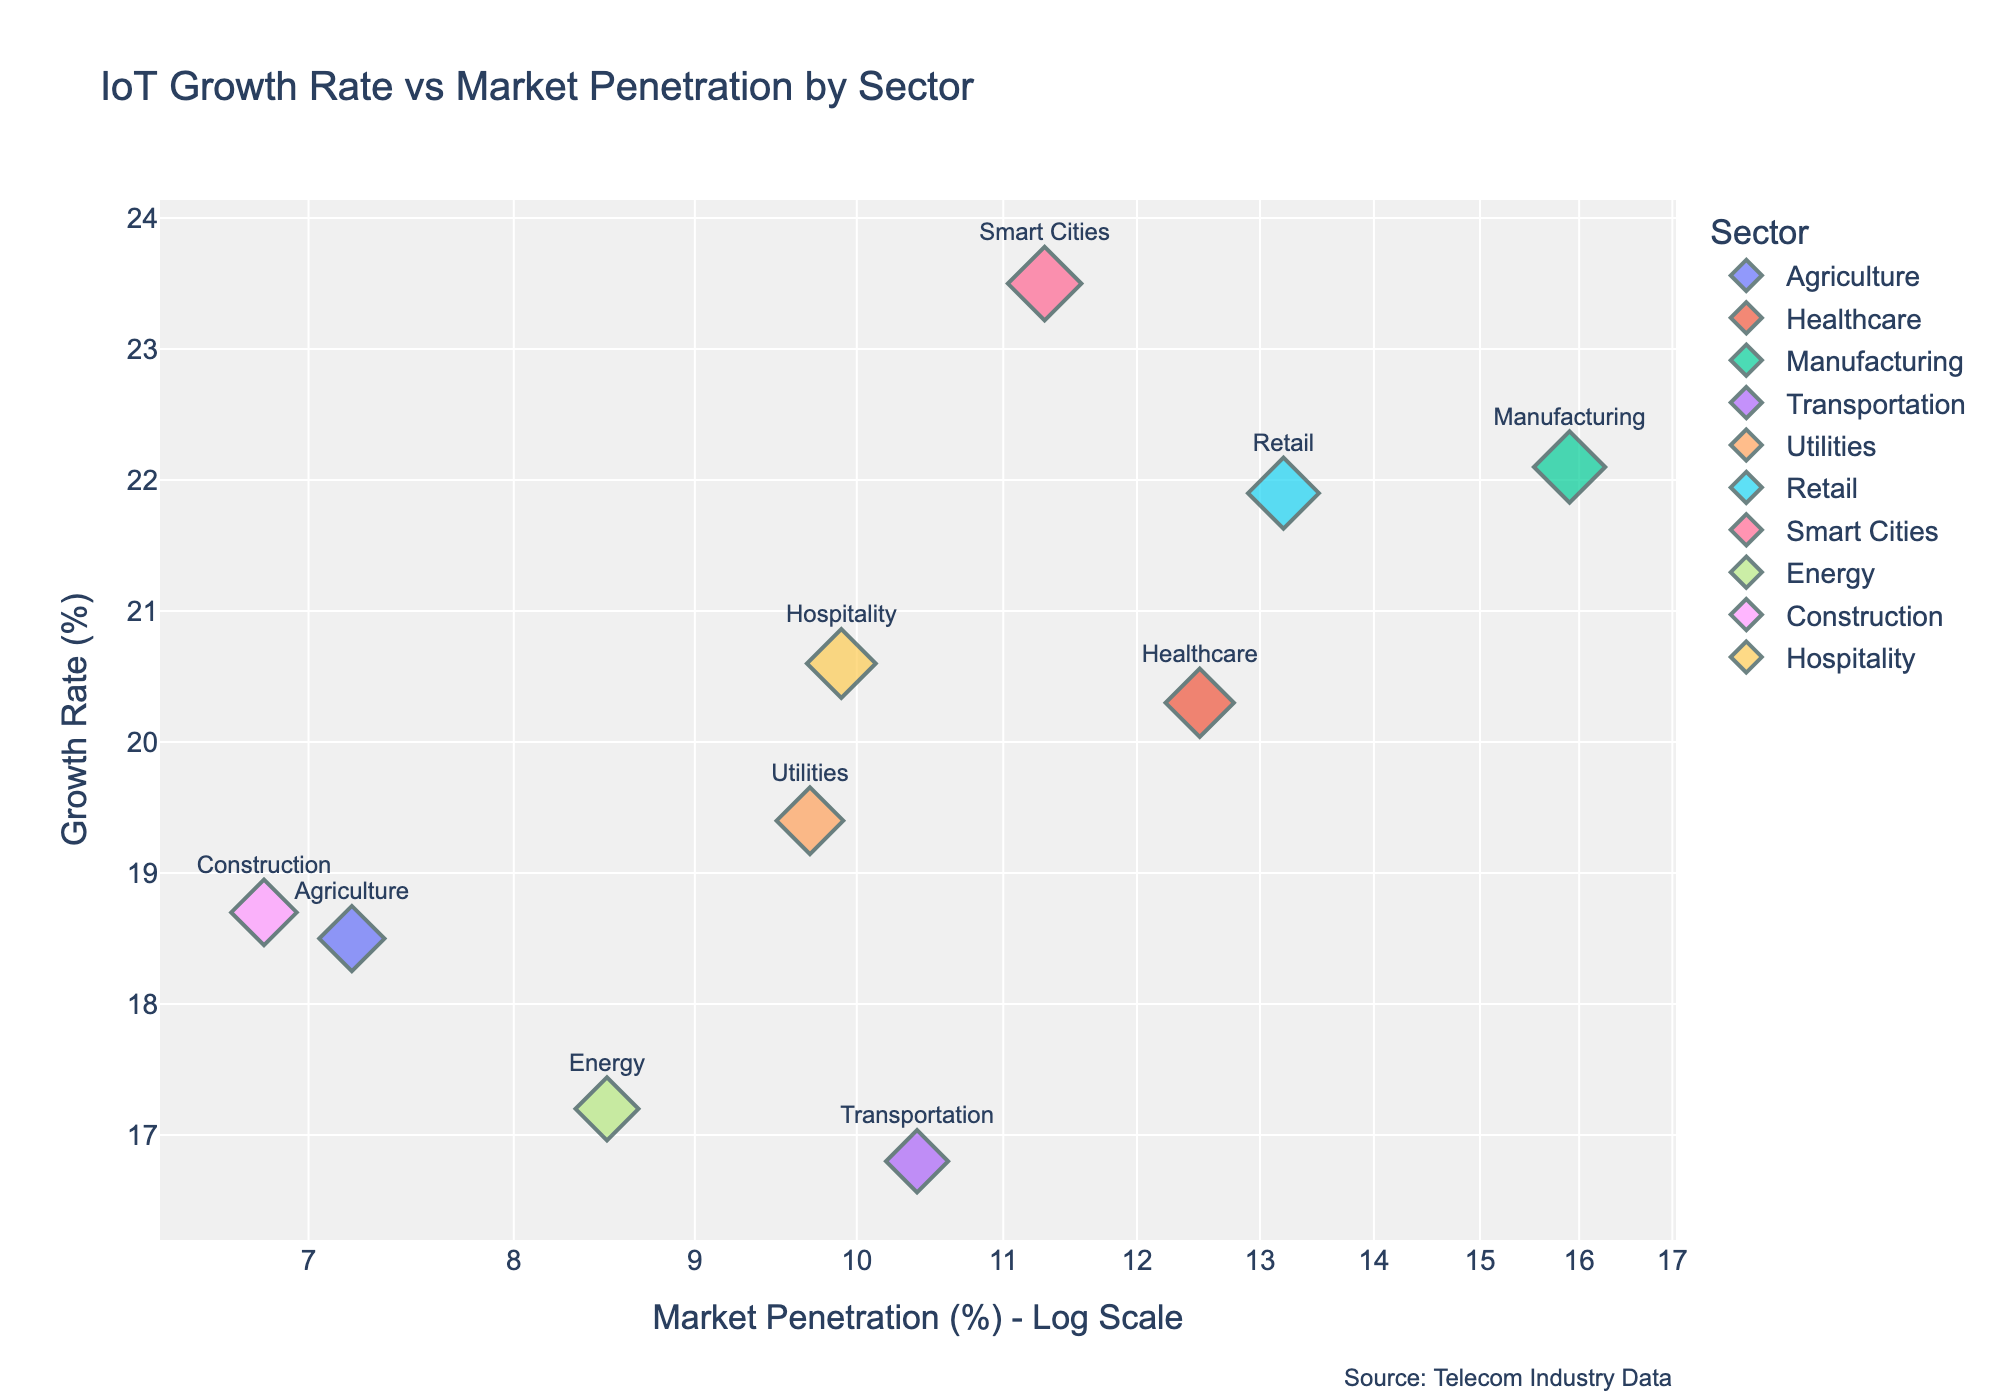What are the axes titles in the scatter plot? The x-axis title is "Market Penetration (%) - Log Scale" and the y-axis title is "Growth Rate (%)". These provide information about the metrics being measured and displayed on each axis.
Answer: "Market Penetration (%) - Log Scale" and "Growth Rate (%)" How many sectors are represented in the scatter plot? There are data points labeled with different sectors on the plot. Counting these labels gives the number of sectors. There are 10 sectors displayed on the plot.
Answer: 10 Which sector has the highest growth rate? Look for the data point positioned the highest on the y-axis labeled with a sector name. The "Smart Cities" sector is at the topmost position with a growth rate of 23.5%.
Answer: Smart Cities What is the market penetration percentage for the Energy sector? Find the data point labeled as "Energy" and check its position on the x-axis. The market penetration percentage for Energy is 8.5%.
Answer: 8.5% Which sector has the lowest market penetration percentage? Identify the leftmost data point on the x-axis labeled with a sector name. The "Construction" sector is the leftmost point with a market penetration of 6.8%.
Answer: Construction What is the difference in growth rate between the Manufacturing and Retail sectors? Locate the data points labeled "Manufacturing" and "Retail" on the y-axis. The growth rate for Manufacturing is 22.1% and for Retail, it is 21.9%. The difference is 22.1% - 21.9% = 0.2%.
Answer: 0.2% Which sector has a growth rate greater than 20% and a market penetration less than 10%? Identify the data points with a growth rate value above 20% on the y-axis and with a market penetration value left of 10 on the log-scaled x-axis. The "Healthcare" sector meets these criteria.
Answer: Healthcare How does the transportation sector's growth rate compare to the average growth rate of all sectors? First, calculate the average growth rate of all sectors by summing up the growth rates and dividing by the number of sectors. Then compare it to the growth rate of the Transportation sector. Average growth rate = (18.5 + 20.3 + 22.1 + 16.8 + 19.4 + 21.9 + 23.5 + 17.2 + 18.7 + 20.6) / 10 = 19.9%. The Transportation sector's growth rate is 16.8%, which is lower than the average.
Answer: Lower Is there a positive correlation between market penetration and growth rate among sectors? Check if data points generally move upward in the y-axis as they move rightward in the x-axis. There isn't a clearly positive correlation since the points are relatively dispersed without a clear trend line.
Answer: No 